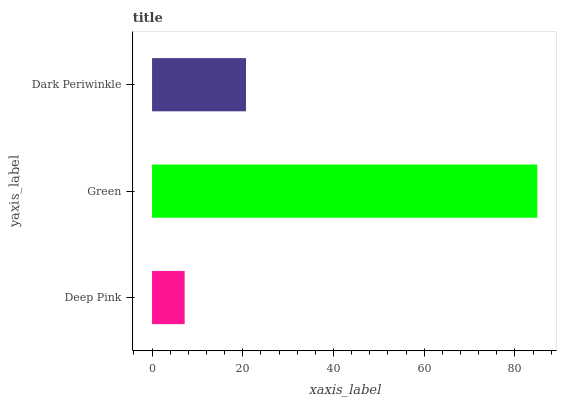Is Deep Pink the minimum?
Answer yes or no. Yes. Is Green the maximum?
Answer yes or no. Yes. Is Dark Periwinkle the minimum?
Answer yes or no. No. Is Dark Periwinkle the maximum?
Answer yes or no. No. Is Green greater than Dark Periwinkle?
Answer yes or no. Yes. Is Dark Periwinkle less than Green?
Answer yes or no. Yes. Is Dark Periwinkle greater than Green?
Answer yes or no. No. Is Green less than Dark Periwinkle?
Answer yes or no. No. Is Dark Periwinkle the high median?
Answer yes or no. Yes. Is Dark Periwinkle the low median?
Answer yes or no. Yes. Is Green the high median?
Answer yes or no. No. Is Deep Pink the low median?
Answer yes or no. No. 